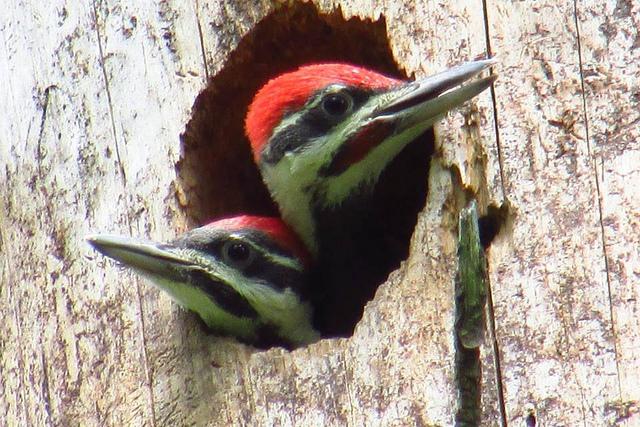How many animals are in the image?
Answer briefly. 2. What color is the top of the animals head?
Short answer required. Red. Are these animals young or old?
Be succinct. Young. 